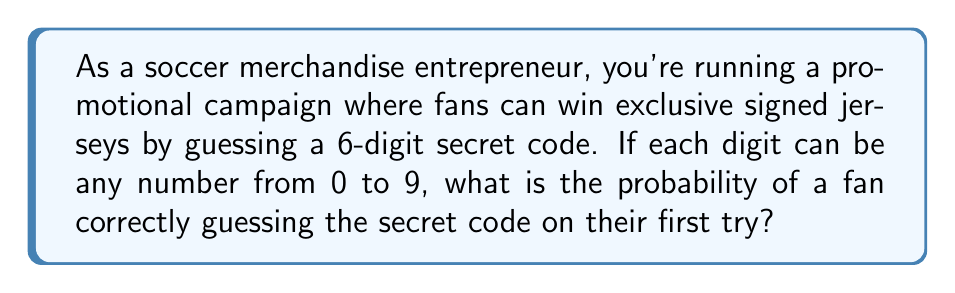Provide a solution to this math problem. Let's approach this step-by-step:

1) First, we need to determine the total number of possible 6-digit codes:
   - Each digit can be any number from 0 to 9, so there are 10 possibilities for each digit.
   - There are 6 digits in total.
   - The total number of possible codes is therefore:
     $$ 10 \times 10 \times 10 \times 10 \times 10 \times 10 = 10^6 = 1,000,000 $$

2) Now, we need to consider how many ways there are to guess the correct code:
   - There is only one correct code out of all the possibilities.

3) The probability of an event is calculated by dividing the number of favorable outcomes by the total number of possible outcomes:

   $$ P(\text{correct guess}) = \frac{\text{number of correct codes}}{\text{total number of possible codes}} = \frac{1}{1,000,000} = 10^{-6} $$

Therefore, the probability of a fan correctly guessing the secret code on their first try is $\frac{1}{1,000,000}$ or $10^{-6}$.
Answer: $\frac{1}{1,000,000}$ or $10^{-6}$ 